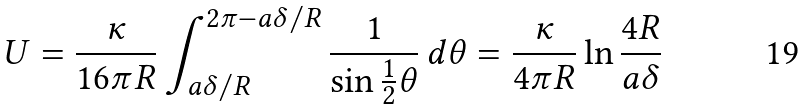Convert formula to latex. <formula><loc_0><loc_0><loc_500><loc_500>U = { \frac { \kappa } { 1 6 \pi R } } \int _ { a \delta / R } ^ { 2 \pi - a \delta / R } { \frac { 1 } { \sin { \frac { 1 } { 2 } } \theta } } \, d \theta = { \frac { \kappa } { 4 \pi R } } \ln { \frac { 4 R } { a \delta } }</formula> 